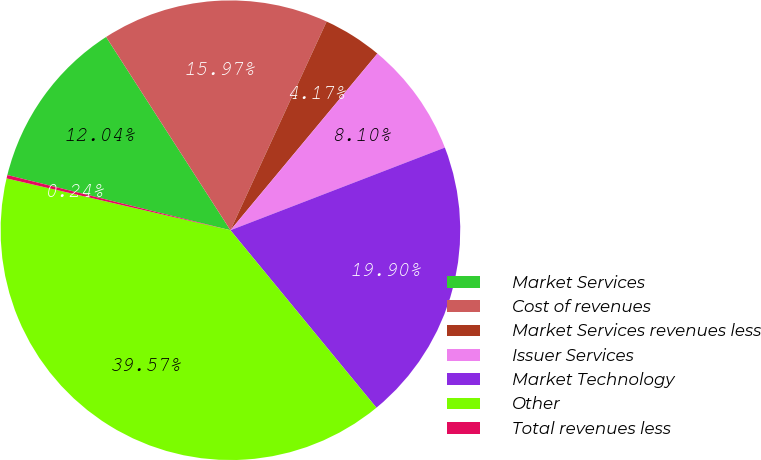Convert chart to OTSL. <chart><loc_0><loc_0><loc_500><loc_500><pie_chart><fcel>Market Services<fcel>Cost of revenues<fcel>Market Services revenues less<fcel>Issuer Services<fcel>Market Technology<fcel>Other<fcel>Total revenues less<nl><fcel>12.04%<fcel>15.97%<fcel>4.17%<fcel>8.1%<fcel>19.9%<fcel>39.57%<fcel>0.24%<nl></chart> 